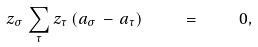Convert formula to latex. <formula><loc_0><loc_0><loc_500><loc_500>z _ { \sigma } \, \sum _ { \tau } z _ { \tau } \, ( { a } _ { \sigma } \, - \, { a } _ { \tau } ) \quad = \quad 0 ,</formula> 